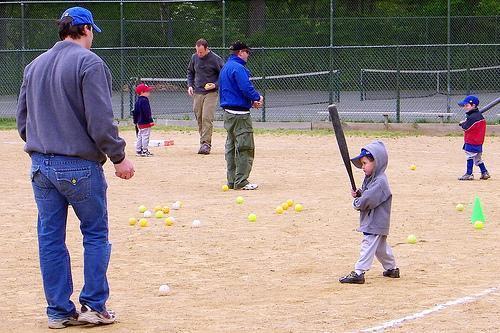How many kids have bats?
Give a very brief answer. 2. How many adults are there?
Give a very brief answer. 3. How many kids with bats are wearing a gray hoodie?
Give a very brief answer. 1. How many of the people are wearing olive green pants?
Give a very brief answer. 1. 